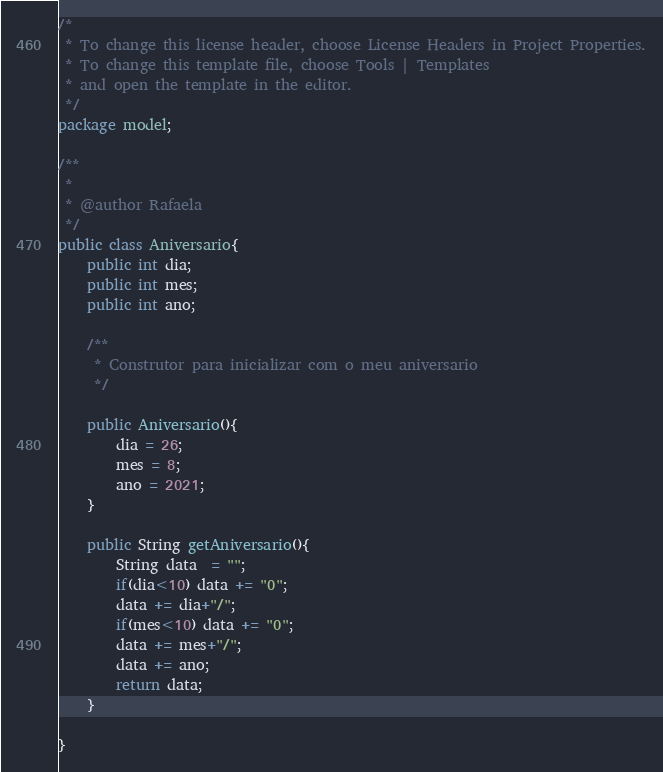<code> <loc_0><loc_0><loc_500><loc_500><_Java_>/*
 * To change this license header, choose License Headers in Project Properties.
 * To change this template file, choose Tools | Templates
 * and open the template in the editor.
 */
package model;

/**
 *
 * @author Rafaela
 */
public class Aniversario{
    public int dia;
    public int mes;
    public int ano;
    
    /**
     * Construtor para inicializar com o meu aniversario
     */
    
    public Aniversario(){
        dia = 26;
        mes = 8;
        ano = 2021;
    }
    
    public String getAniversario(){
        String data  = "";
        if(dia<10) data += "0";
        data += dia+"/";
        if(mes<10) data += "0";
        data += mes+"/";
        data += ano;
        return data;
    }
    
}
</code> 